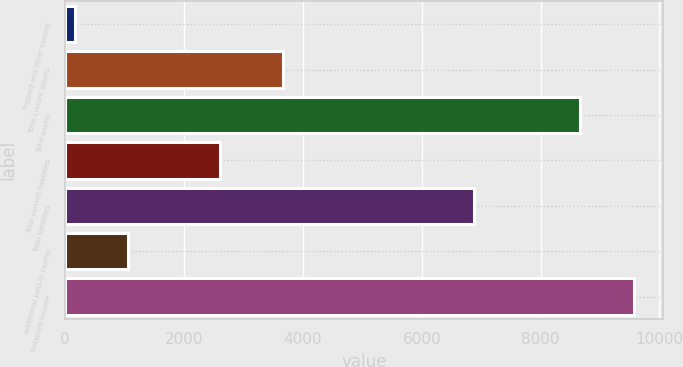<chart> <loc_0><loc_0><loc_500><loc_500><bar_chart><fcel>Prepaid and other current<fcel>Total current assets<fcel>Total assets<fcel>Total current liabilities<fcel>Total liabilities<fcel>Additional paid-in capital<fcel>Retained income<nl><fcel>157<fcel>3671<fcel>8669<fcel>2611<fcel>6888<fcel>1062.3<fcel>9574.3<nl></chart> 